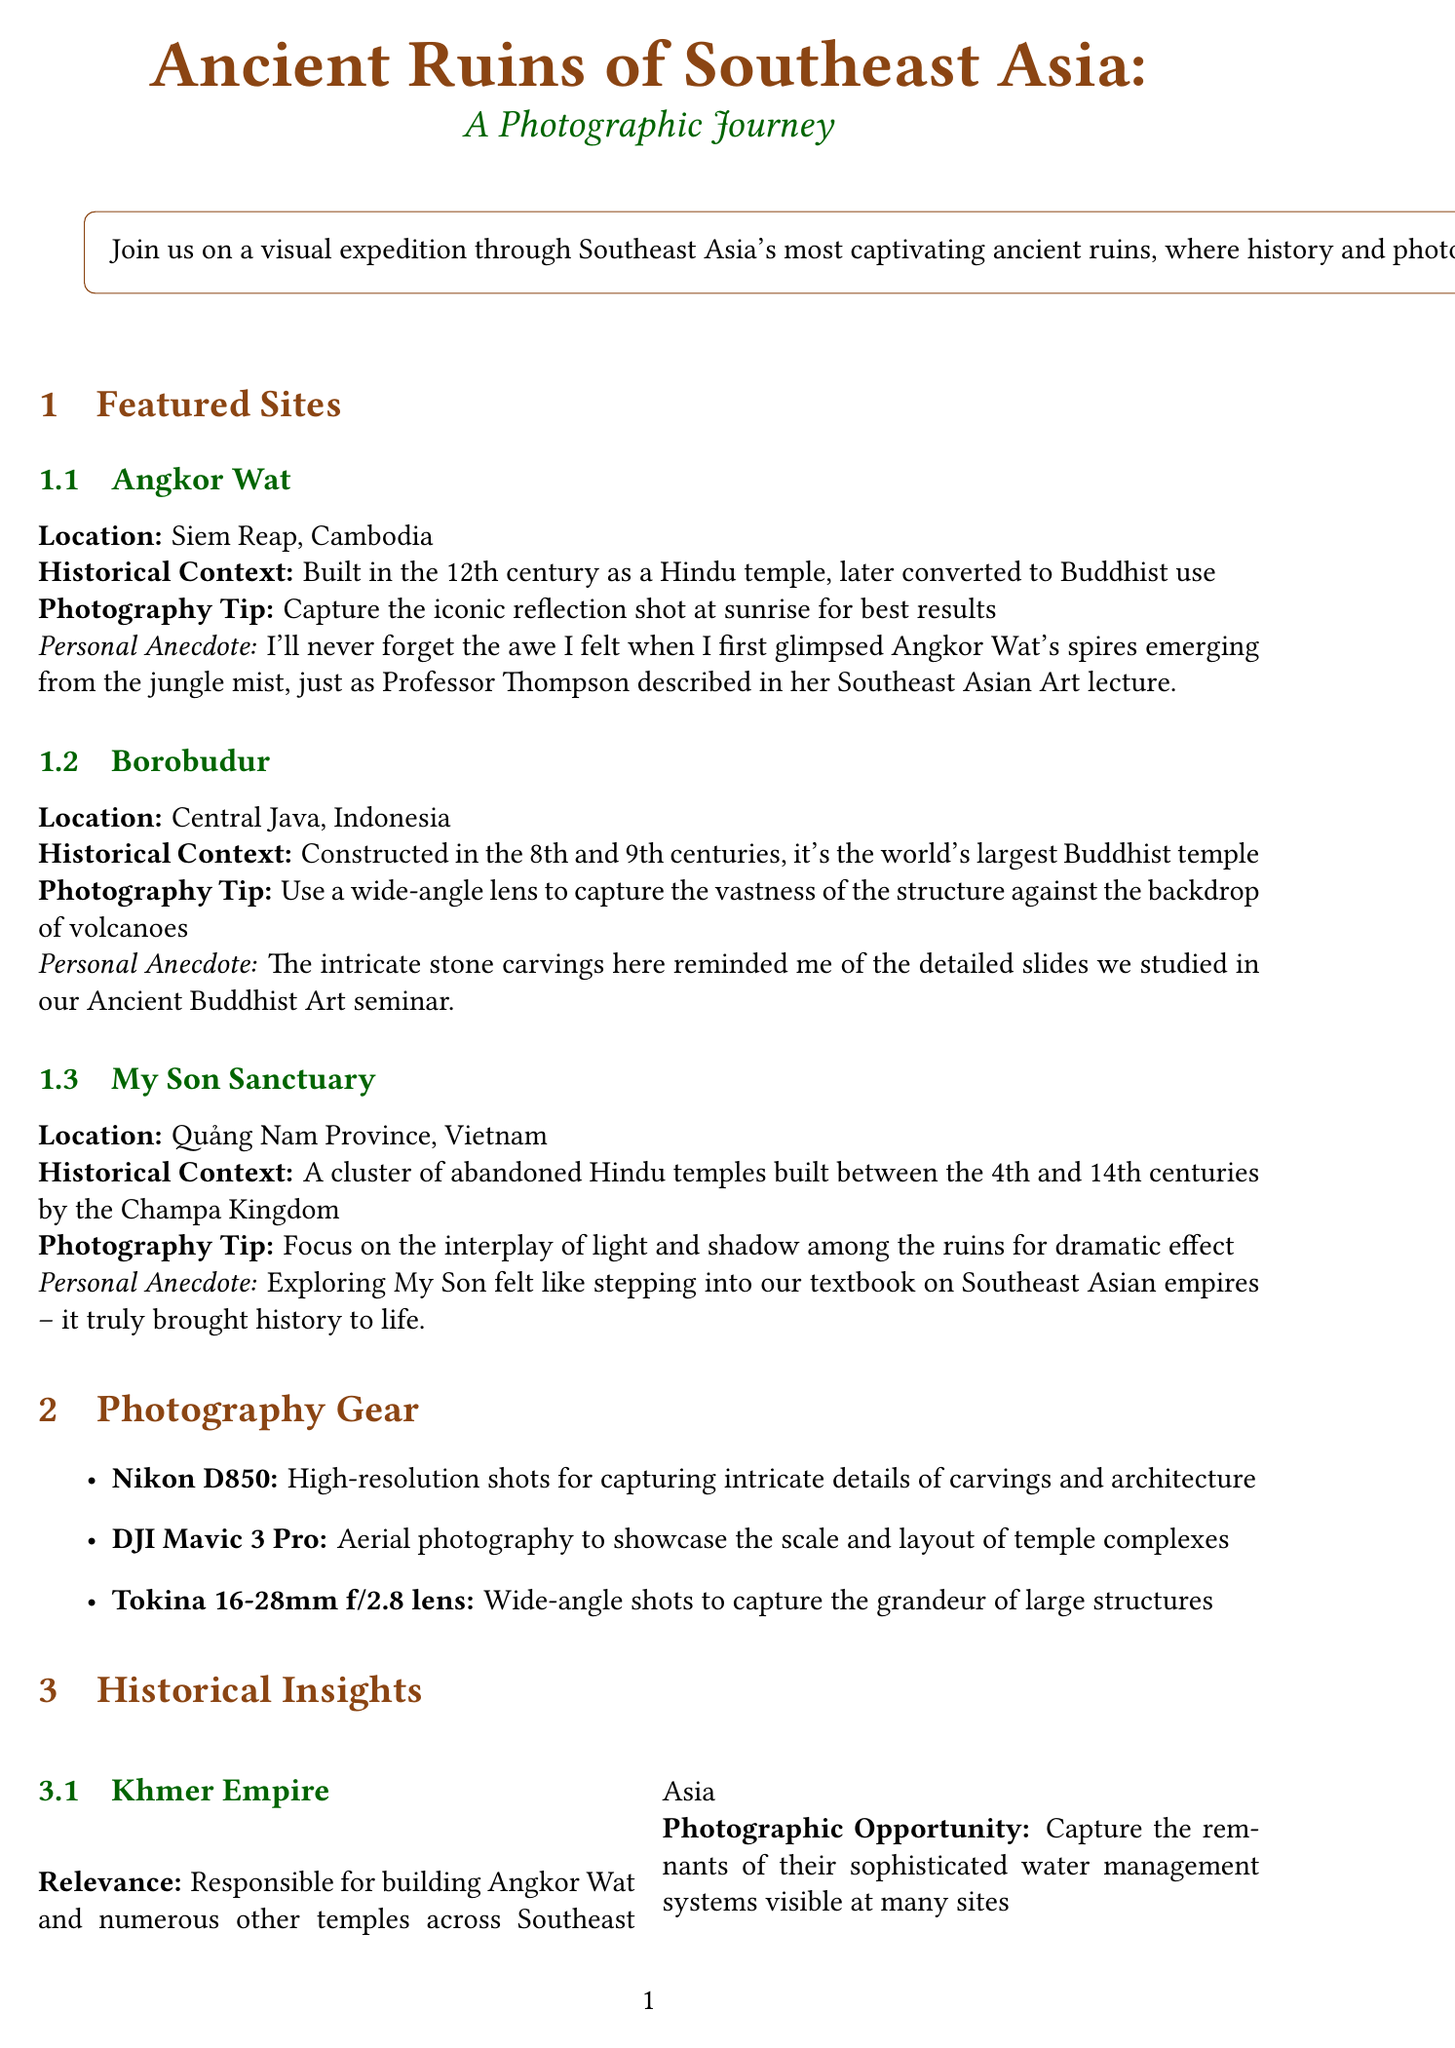what is the title of the newsletter? The title of the newsletter is mentioned at the beginning of the document.
Answer: Ancient Ruins of Southeast Asia: A Photographic Journey where is Angkor Wat located? The location of Angkor Wat is specified in the featured sites section.
Answer: Siem Reap, Cambodia what century was Borobudur constructed? The construction period of Borobudur is detailed in its historical context.
Answer: 8th and 9th centuries what organization is mentioned for preservation efforts? The document discusses preservation efforts and names a specific organization.
Answer: UNESCO World Heritage Centre what photography tip is suggested for My Son Sanctuary? The photography tips for each site are listed under the featured sites section.
Answer: Focus on the interplay of light and shadow among the ruins for dramatic effect which empire built Angkor Wat? The historical insights section provides information about the empire responsible for Angkor Wat.
Answer: Khmer Empire what is the relevance of Hindu-Buddhist Syncretic Art? The document addresses the significance of Hindu-Buddhist Syncretic Art in the historical insights section.
Answer: Many ruins showcase a blend of Hindu and Buddhist iconography what photography gear is recommended for capturing intricate details? The photography gear recommendations are detailed in the gear section of the document.
Answer: Nikon D850 how many ancient temples are specified in My Son Sanctuary? Although exact numbers are not mentioned, the document states a range for the temples built by a particular kingdom.
Answer: 4th to 14th centuries 